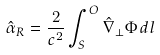Convert formula to latex. <formula><loc_0><loc_0><loc_500><loc_500>\hat { \alpha } _ { R } = \frac { 2 } { c ^ { 2 } } \int _ { S } ^ { O } \hat { \nabla } _ { \perp } \Phi \, d l \,</formula> 